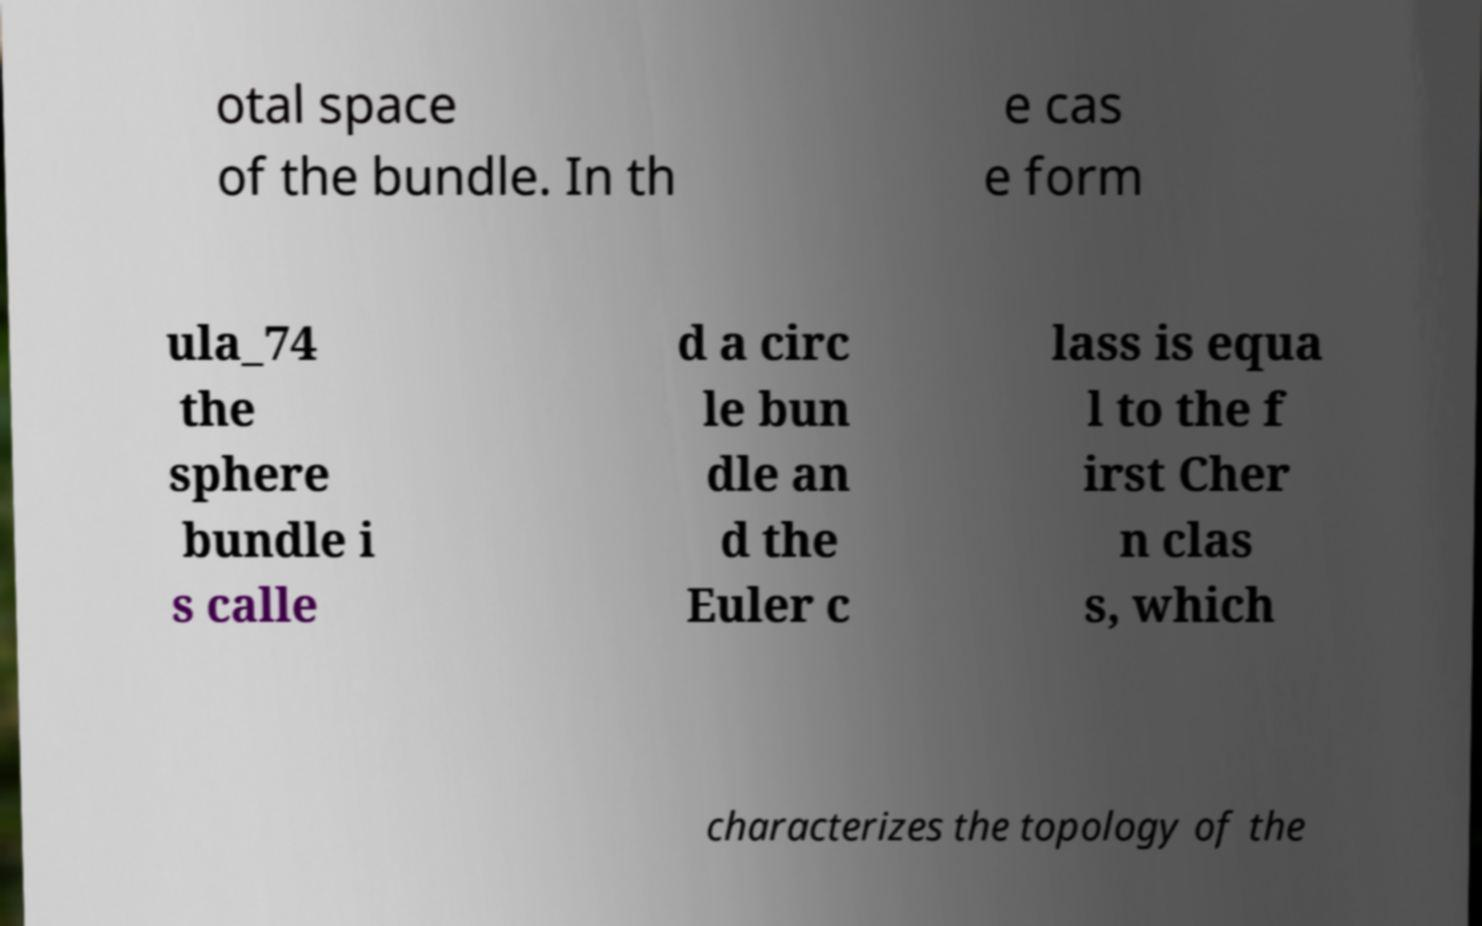Can you accurately transcribe the text from the provided image for me? otal space of the bundle. In th e cas e form ula_74 the sphere bundle i s calle d a circ le bun dle an d the Euler c lass is equa l to the f irst Cher n clas s, which characterizes the topology of the 